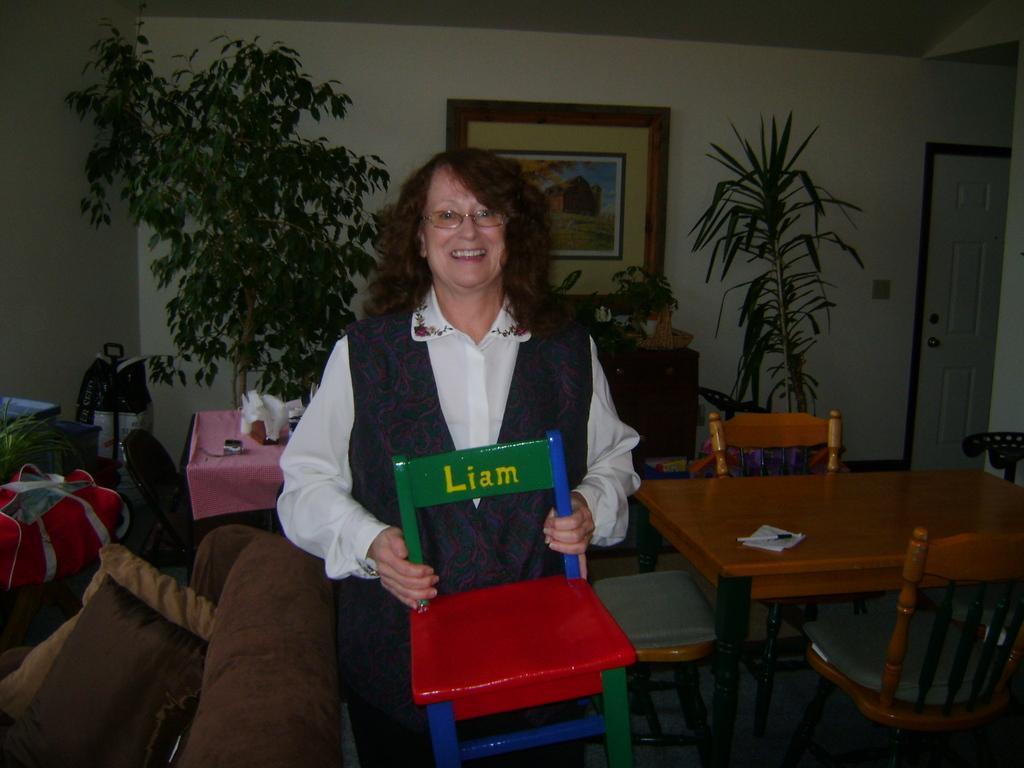Could you give a brief overview of what you see in this image? In this picture I can observe a woman. She is holding a toy chair in her hands. She is smiling. On the left side I can observe sofa. On the right side I can observe table and chairs. In the background there are trees and photo frame on the wall. 